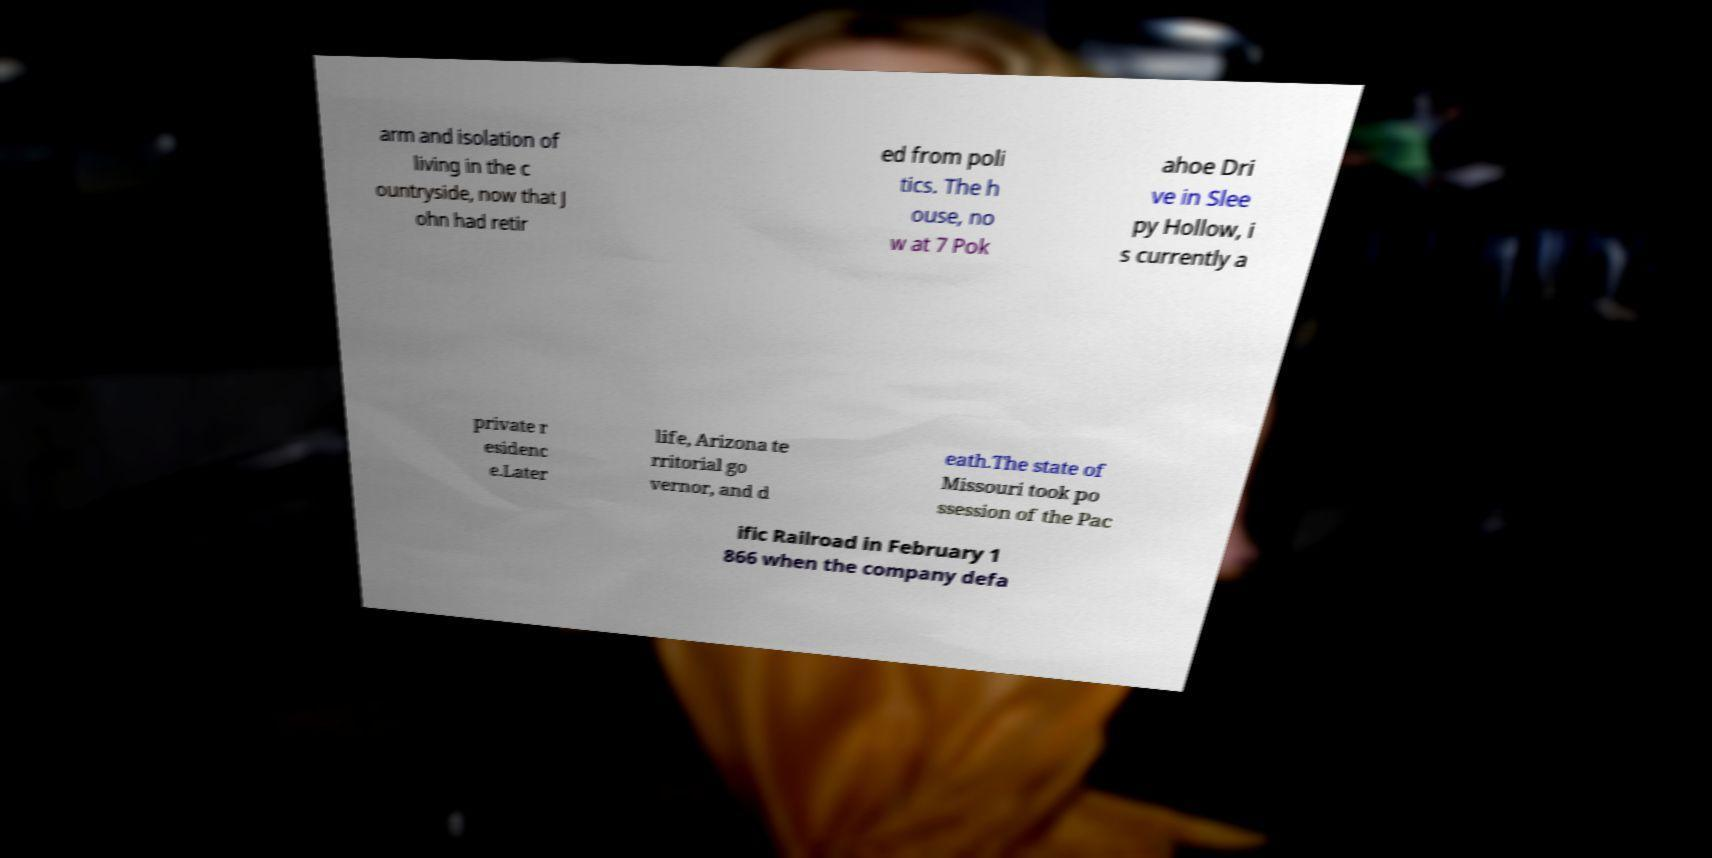I need the written content from this picture converted into text. Can you do that? arm and isolation of living in the c ountryside, now that J ohn had retir ed from poli tics. The h ouse, no w at 7 Pok ahoe Dri ve in Slee py Hollow, i s currently a private r esidenc e.Later life, Arizona te rritorial go vernor, and d eath.The state of Missouri took po ssession of the Pac ific Railroad in February 1 866 when the company defa 